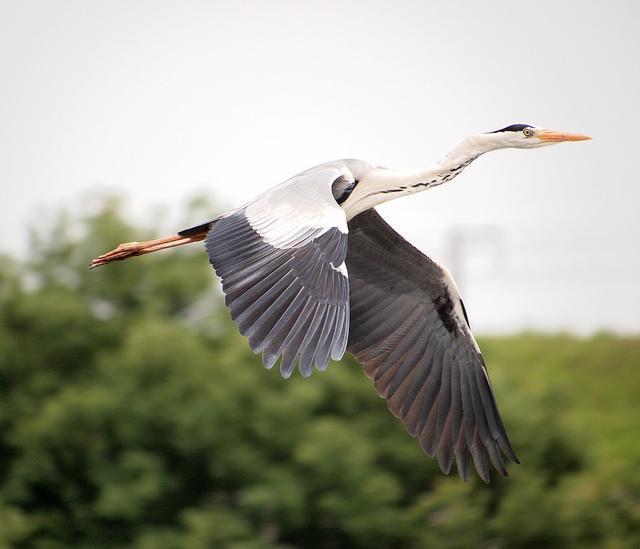How many bus tires can you count?
Give a very brief answer. 0. 